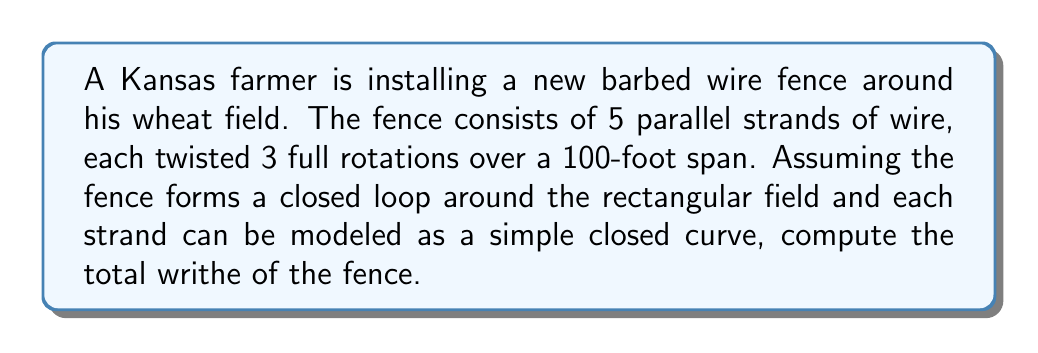Give your solution to this math problem. Let's approach this step-by-step:

1) First, we need to understand what writhe is. The writhe of a closed curve is the sum of the signed crossings in a regular projection of the curve.

2) In this case, each strand of wire can be considered a closed curve (as it goes around the entire field).

3) For a single full twist of a wire, the writhe is approximately 1. This is because a full twist creates one positive crossing when viewed from above.

4) Each strand has 3 full rotations, so the writhe of a single strand is:

   $$ W_{strand} = 3 $$

5) There are 5 parallel strands, and the writhe is additive for separate components. So we multiply the writhe of one strand by 5:

   $$ W_{total} = 5 \times W_{strand} = 5 \times 3 = 15 $$

6) Note: The actual shape of the field (rectangular in this case) doesn't affect the writhe calculation as long as the fence forms a closed loop.

7) Also, the length of the fence (100 feet) is not directly relevant to the writhe calculation, but it helps visualize the density of twists.
Answer: 15 